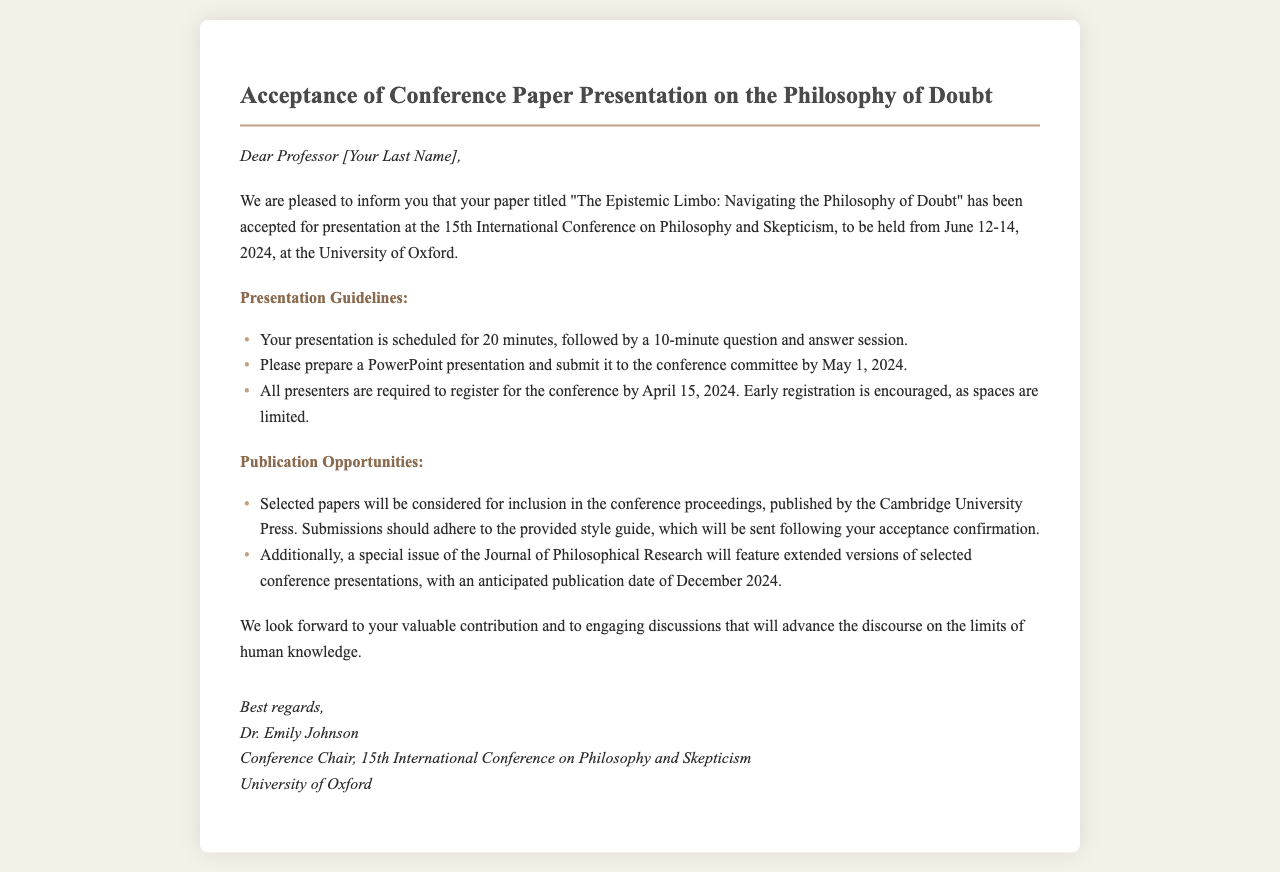What is the title of the accepted paper? The title "The Epistemic Limbo: Navigating the Philosophy of Doubt" is mentioned in the document as the accepted paper.
Answer: The Epistemic Limbo: Navigating the Philosophy of Doubt What are the conference dates? The document states that the conference will be held from June 12-14, 2024.
Answer: June 12-14, 2024 Where is the conference taking place? The document indicates that the conference will be held at the University of Oxford.
Answer: University of Oxford What is the duration of the presentation? The document specifies that the presentation is scheduled for 20 minutes, followed by a 10-minute Q&A session.
Answer: 20 minutes When is the deadline to submit the PowerPoint presentation? The document mentions that the PowerPoint presentation should be submitted by May 1, 2024.
Answer: May 1, 2024 What are the consequences of not registering by April 15, 2024? The document emphasizes that registration is required by April 15, 2024, with early registration encouraged due to limited spaces, implying potential denial of participation if not registered.
Answer: Limited spaces What is the publication opportunity mentioned for selected papers? The document states that selected papers will be considered for inclusion in the conference proceedings published by Cambridge University Press.
Answer: Cambridge University Press When is the anticipated publication date for the special issue of the Journal of Philosophical Research? The document notes that the anticipated publication date is December 2024.
Answer: December 2024 Who is the conference chair? The document identifies Dr. Emily Johnson as the Conference Chair.
Answer: Dr. Emily Johnson 